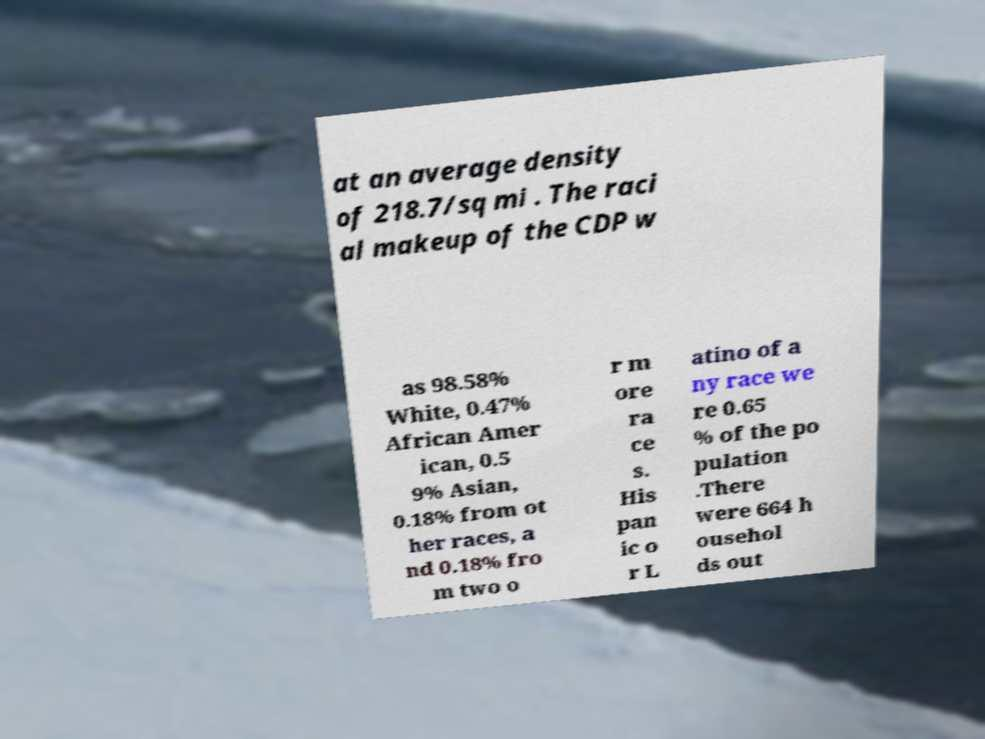Please identify and transcribe the text found in this image. at an average density of 218.7/sq mi . The raci al makeup of the CDP w as 98.58% White, 0.47% African Amer ican, 0.5 9% Asian, 0.18% from ot her races, a nd 0.18% fro m two o r m ore ra ce s. His pan ic o r L atino of a ny race we re 0.65 % of the po pulation .There were 664 h ousehol ds out 